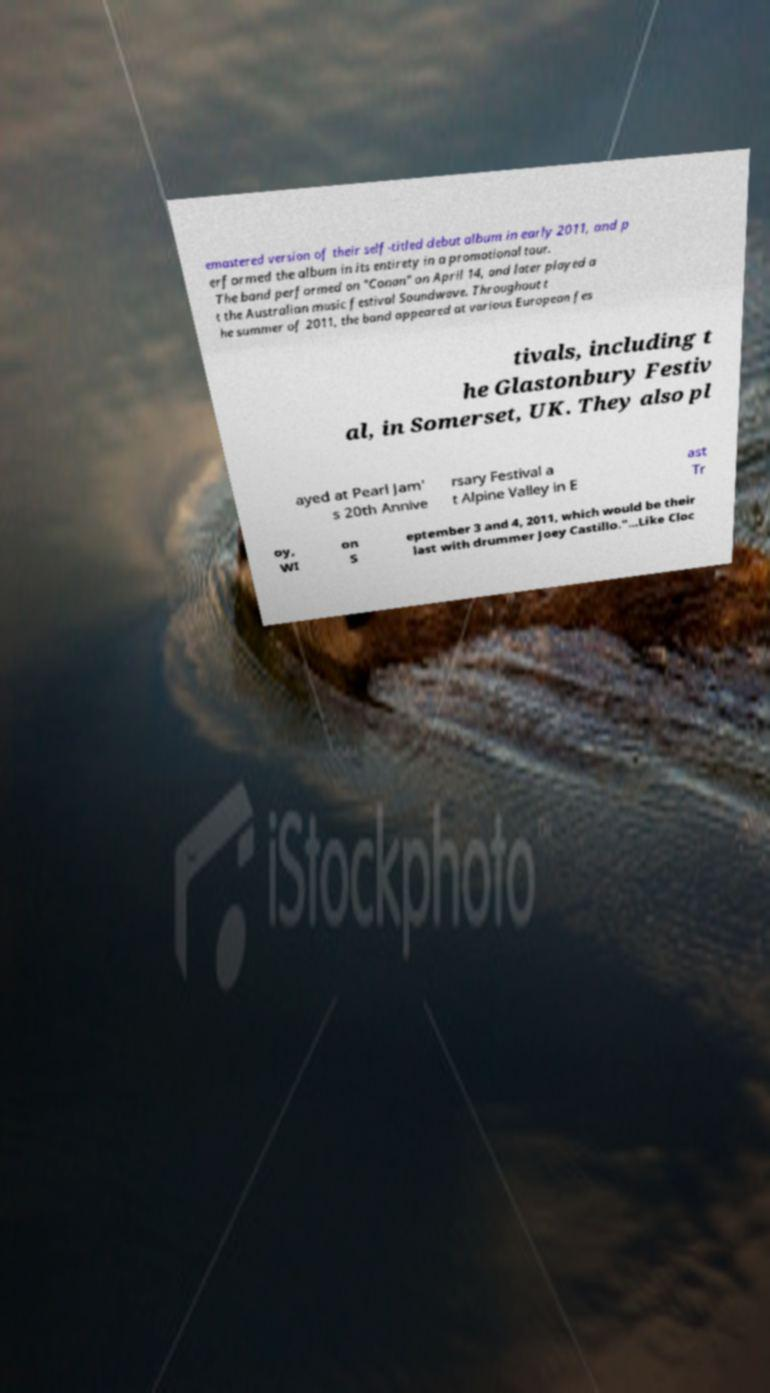Can you read and provide the text displayed in the image?This photo seems to have some interesting text. Can you extract and type it out for me? emastered version of their self-titled debut album in early 2011, and p erformed the album in its entirety in a promotional tour. The band performed on "Conan" on April 14, and later played a t the Australian music festival Soundwave. Throughout t he summer of 2011, the band appeared at various European fes tivals, including t he Glastonbury Festiv al, in Somerset, UK. They also pl ayed at Pearl Jam' s 20th Annive rsary Festival a t Alpine Valley in E ast Tr oy, WI on S eptember 3 and 4, 2011, which would be their last with drummer Joey Castillo."...Like Cloc 